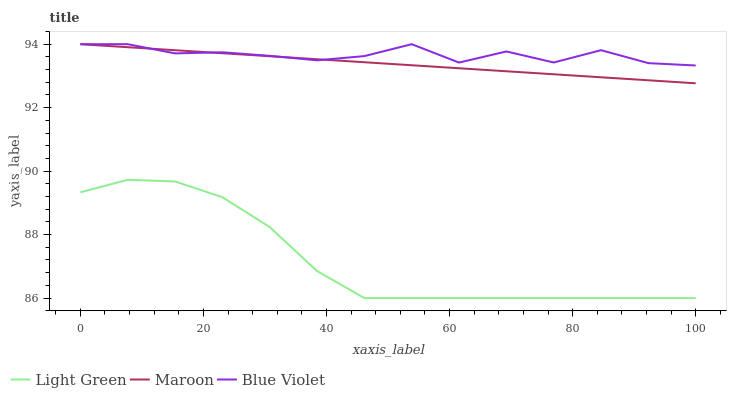Does Light Green have the minimum area under the curve?
Answer yes or no. Yes. Does Blue Violet have the maximum area under the curve?
Answer yes or no. Yes. Does Maroon have the minimum area under the curve?
Answer yes or no. No. Does Maroon have the maximum area under the curve?
Answer yes or no. No. Is Maroon the smoothest?
Answer yes or no. Yes. Is Blue Violet the roughest?
Answer yes or no. Yes. Is Light Green the smoothest?
Answer yes or no. No. Is Light Green the roughest?
Answer yes or no. No. Does Maroon have the lowest value?
Answer yes or no. No. Does Maroon have the highest value?
Answer yes or no. Yes. Does Light Green have the highest value?
Answer yes or no. No. Is Light Green less than Blue Violet?
Answer yes or no. Yes. Is Blue Violet greater than Light Green?
Answer yes or no. Yes. Does Blue Violet intersect Maroon?
Answer yes or no. Yes. Is Blue Violet less than Maroon?
Answer yes or no. No. Is Blue Violet greater than Maroon?
Answer yes or no. No. Does Light Green intersect Blue Violet?
Answer yes or no. No. 